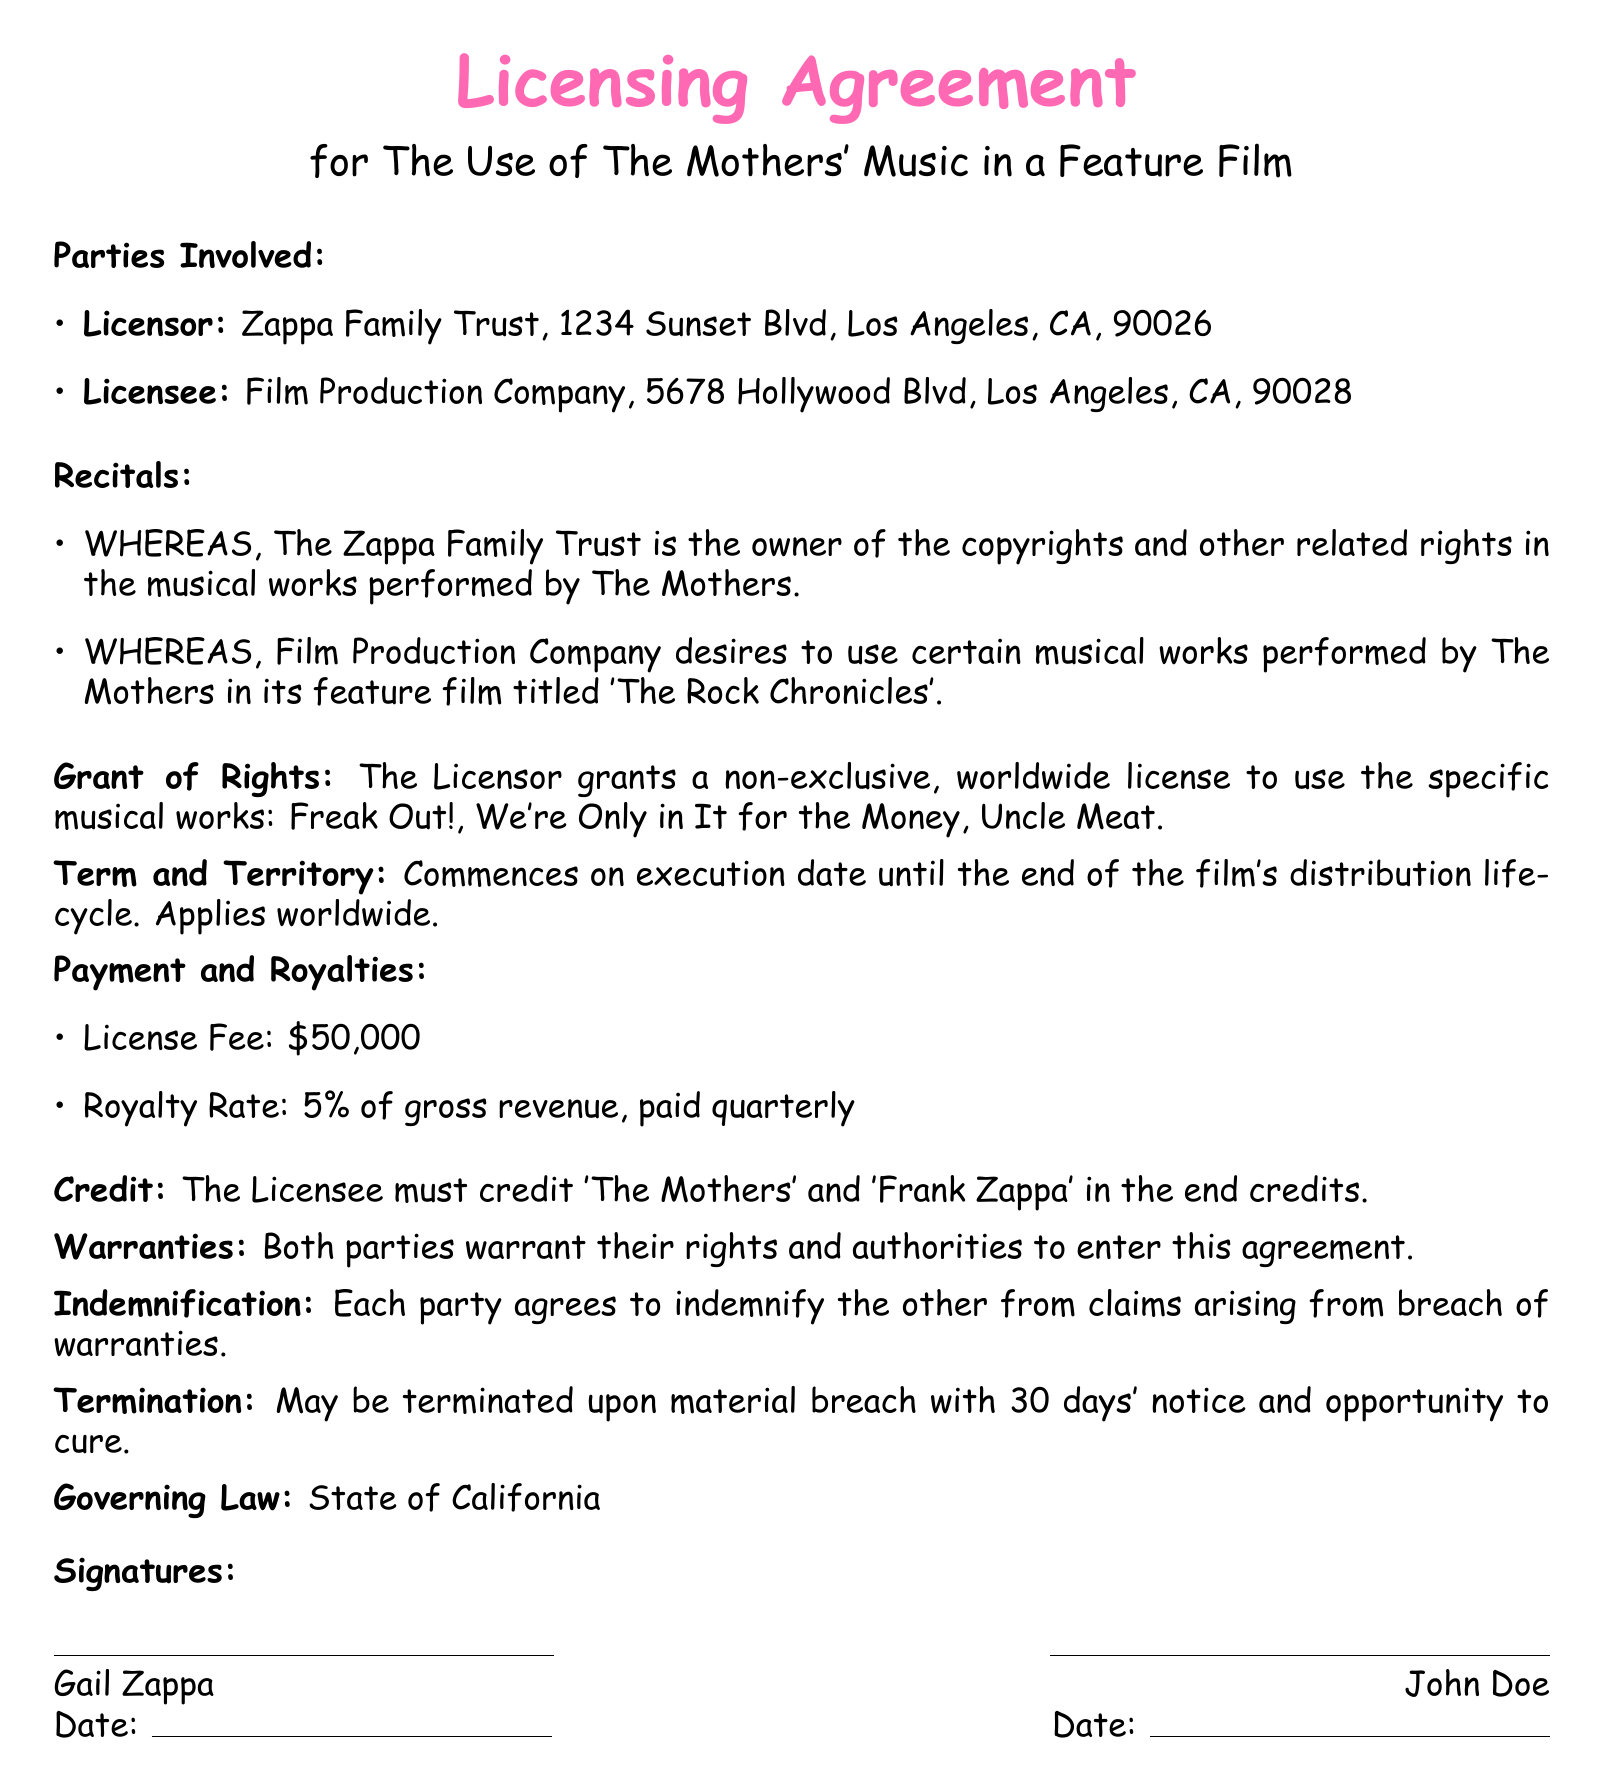what is the name of the feature film? The feature film is the title under which the Licensee wishes to use The Mothers' music, specifically noted in the document.
Answer: The Rock Chronicles who is the Licensor? The Licensor is the entity granting the license, and it is stated as the owner of the copyrights of The Mothers' music.
Answer: Zappa Family Trust what is the license fee? The license fee is explicitly mentioned in the document as the amount the Licensee is required to pay for the rights.
Answer: $50,000 how long is the term of the agreement? The term refers to the duration for which the license is granted, as specified in the document.
Answer: Until the end of the film's distribution lifecycle what percentage of gross revenue is the royalty rate? The royalty rate dictates the percentage of revenue the Licensor receives, as detailed in the payment section of the document.
Answer: 5% what must the Licensee credit in the end credits? The credit refers to how The Mothers and Frank Zappa must be acknowledged in the film, as specified in the document.
Answer: 'The Mothers' and 'Frank Zappa' what can trigger the termination of this agreement? The document specifies events that may justify termination, requiring the Licensee to provide notice.
Answer: Material breach what is the governing law for this agreement? The governing law indicates which jurisdiction's laws will apply to this contract, as mentioned in the document.
Answer: State of California 